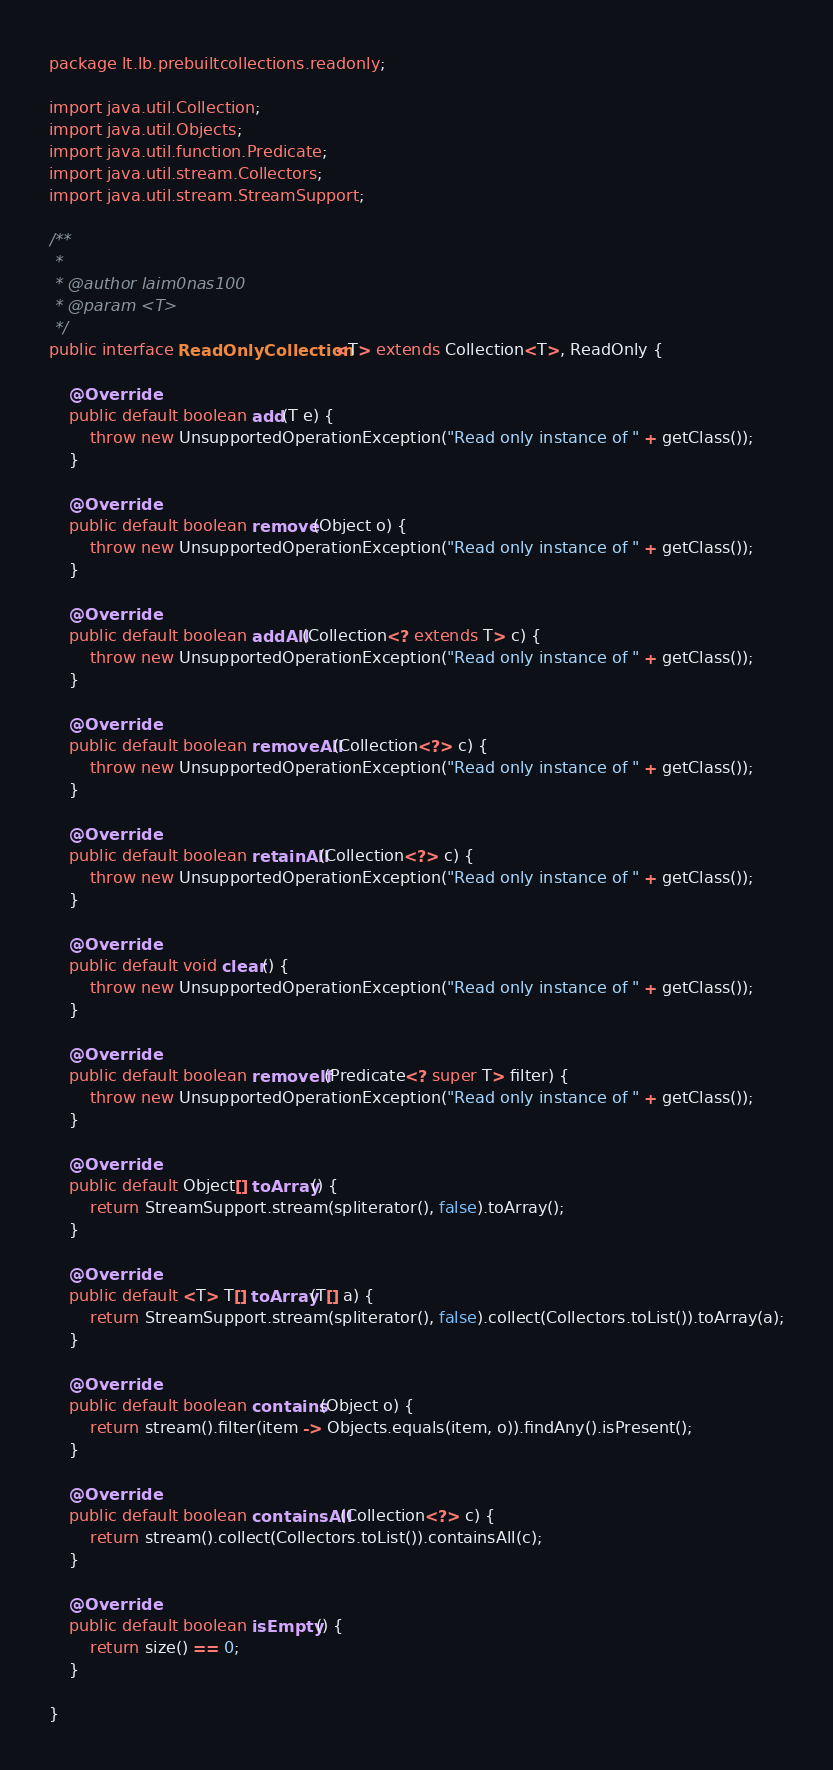<code> <loc_0><loc_0><loc_500><loc_500><_Java_>package lt.lb.prebuiltcollections.readonly;

import java.util.Collection;
import java.util.Objects;
import java.util.function.Predicate;
import java.util.stream.Collectors;
import java.util.stream.StreamSupport;

/**
 *
 * @author laim0nas100
 * @param <T>
 */
public interface ReadOnlyCollection<T> extends Collection<T>, ReadOnly {

    @Override
    public default boolean add(T e) {
        throw new UnsupportedOperationException("Read only instance of " + getClass());
    }

    @Override
    public default boolean remove(Object o) {
        throw new UnsupportedOperationException("Read only instance of " + getClass());
    }

    @Override
    public default boolean addAll(Collection<? extends T> c) {
        throw new UnsupportedOperationException("Read only instance of " + getClass());
    }

    @Override
    public default boolean removeAll(Collection<?> c) {
        throw new UnsupportedOperationException("Read only instance of " + getClass());
    }

    @Override
    public default boolean retainAll(Collection<?> c) {
        throw new UnsupportedOperationException("Read only instance of " + getClass());
    }

    @Override
    public default void clear() {
        throw new UnsupportedOperationException("Read only instance of " + getClass());
    }

    @Override
    public default boolean removeIf(Predicate<? super T> filter) {
        throw new UnsupportedOperationException("Read only instance of " + getClass());
    }

    @Override
    public default Object[] toArray() {
        return StreamSupport.stream(spliterator(), false).toArray();
    }

    @Override
    public default <T> T[] toArray(T[] a) {
        return StreamSupport.stream(spliterator(), false).collect(Collectors.toList()).toArray(a);
    }

    @Override
    public default boolean contains(Object o) {
        return stream().filter(item -> Objects.equals(item, o)).findAny().isPresent();
    }

    @Override
    public default boolean containsAll(Collection<?> c) {
        return stream().collect(Collectors.toList()).containsAll(c);
    }

    @Override
    public default boolean isEmpty() {
        return size() == 0;
    }

}
</code> 